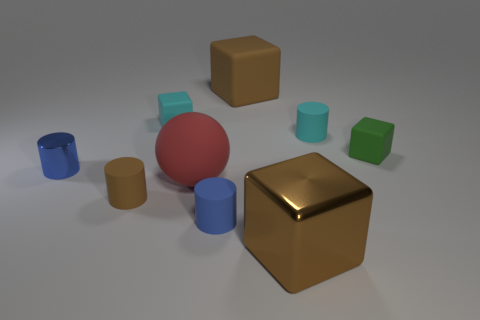Subtract all large brown shiny cubes. How many cubes are left? 3 Subtract all brown cylinders. How many cylinders are left? 3 Add 1 big purple shiny spheres. How many objects exist? 10 Subtract 2 blocks. How many blocks are left? 2 Subtract all cyan balls. How many brown cubes are left? 2 Add 6 big gray matte cylinders. How many big gray matte cylinders exist? 6 Subtract 0 blue balls. How many objects are left? 9 Subtract all cubes. How many objects are left? 5 Subtract all purple spheres. Subtract all green cylinders. How many spheres are left? 1 Subtract all small blue metal things. Subtract all small blue shiny cylinders. How many objects are left? 7 